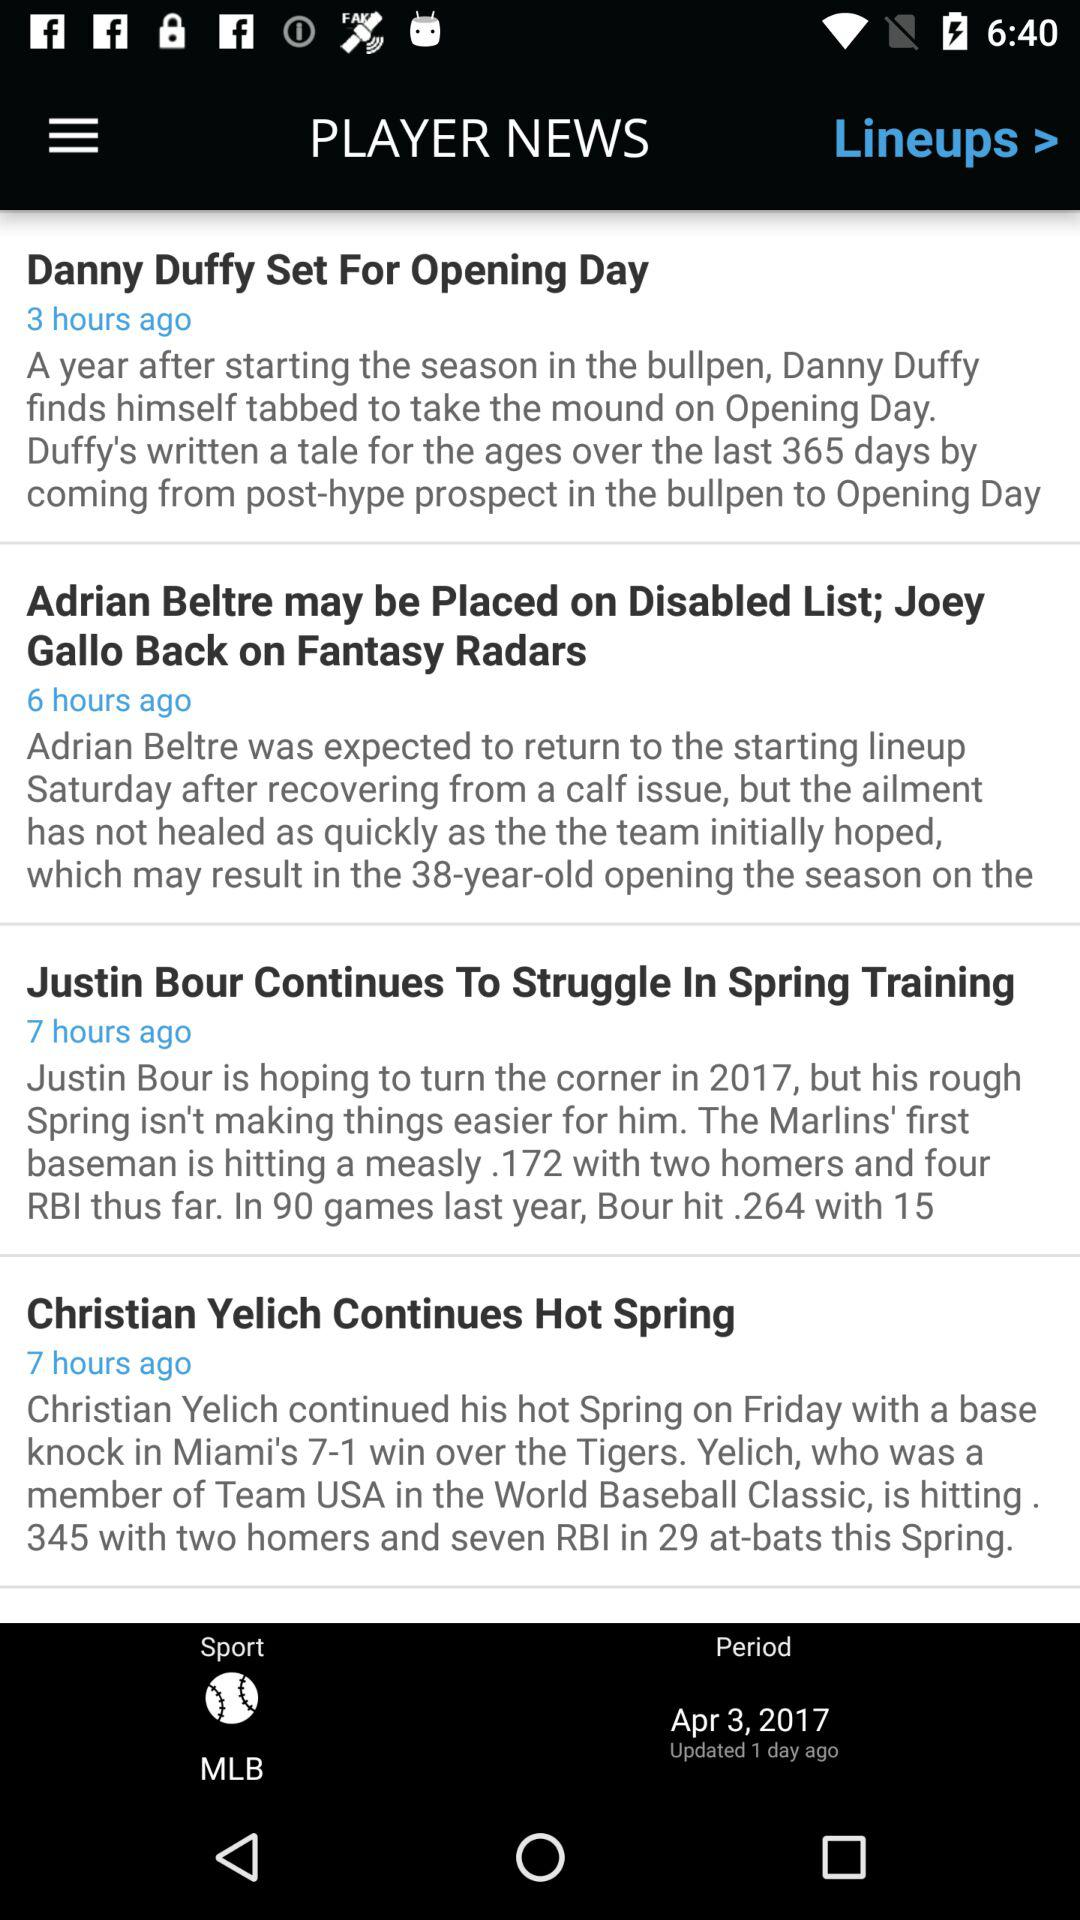How many hours ago was the last article published?
Answer the question using a single word or phrase. 7 hours ago 